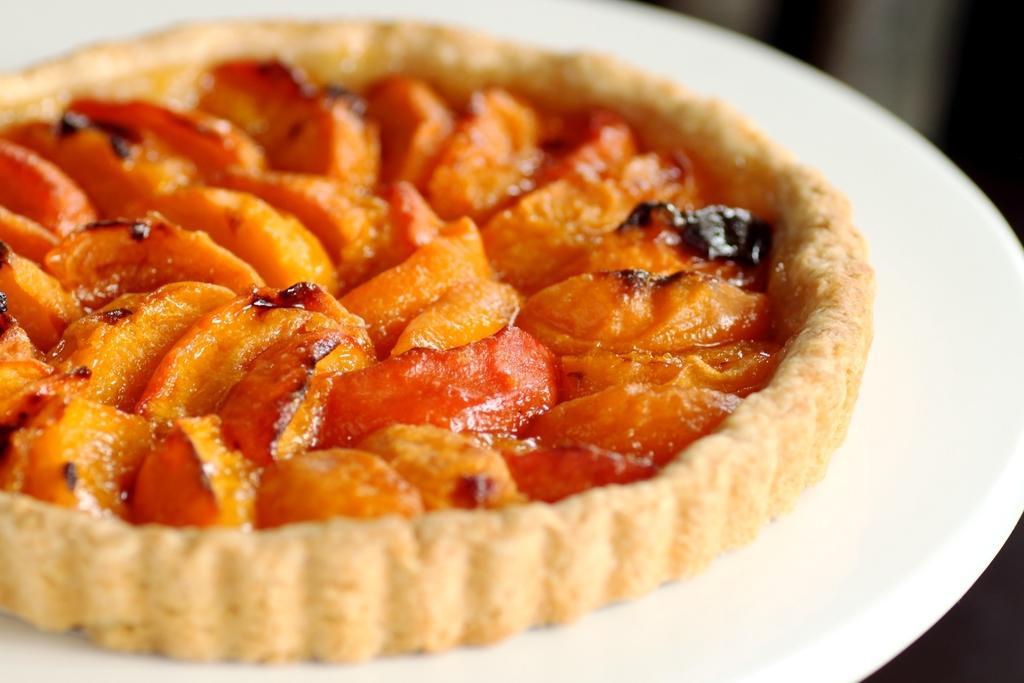Please provide a concise description of this image. As we can see in the image there is a white color plate. On plate there is a dish. 